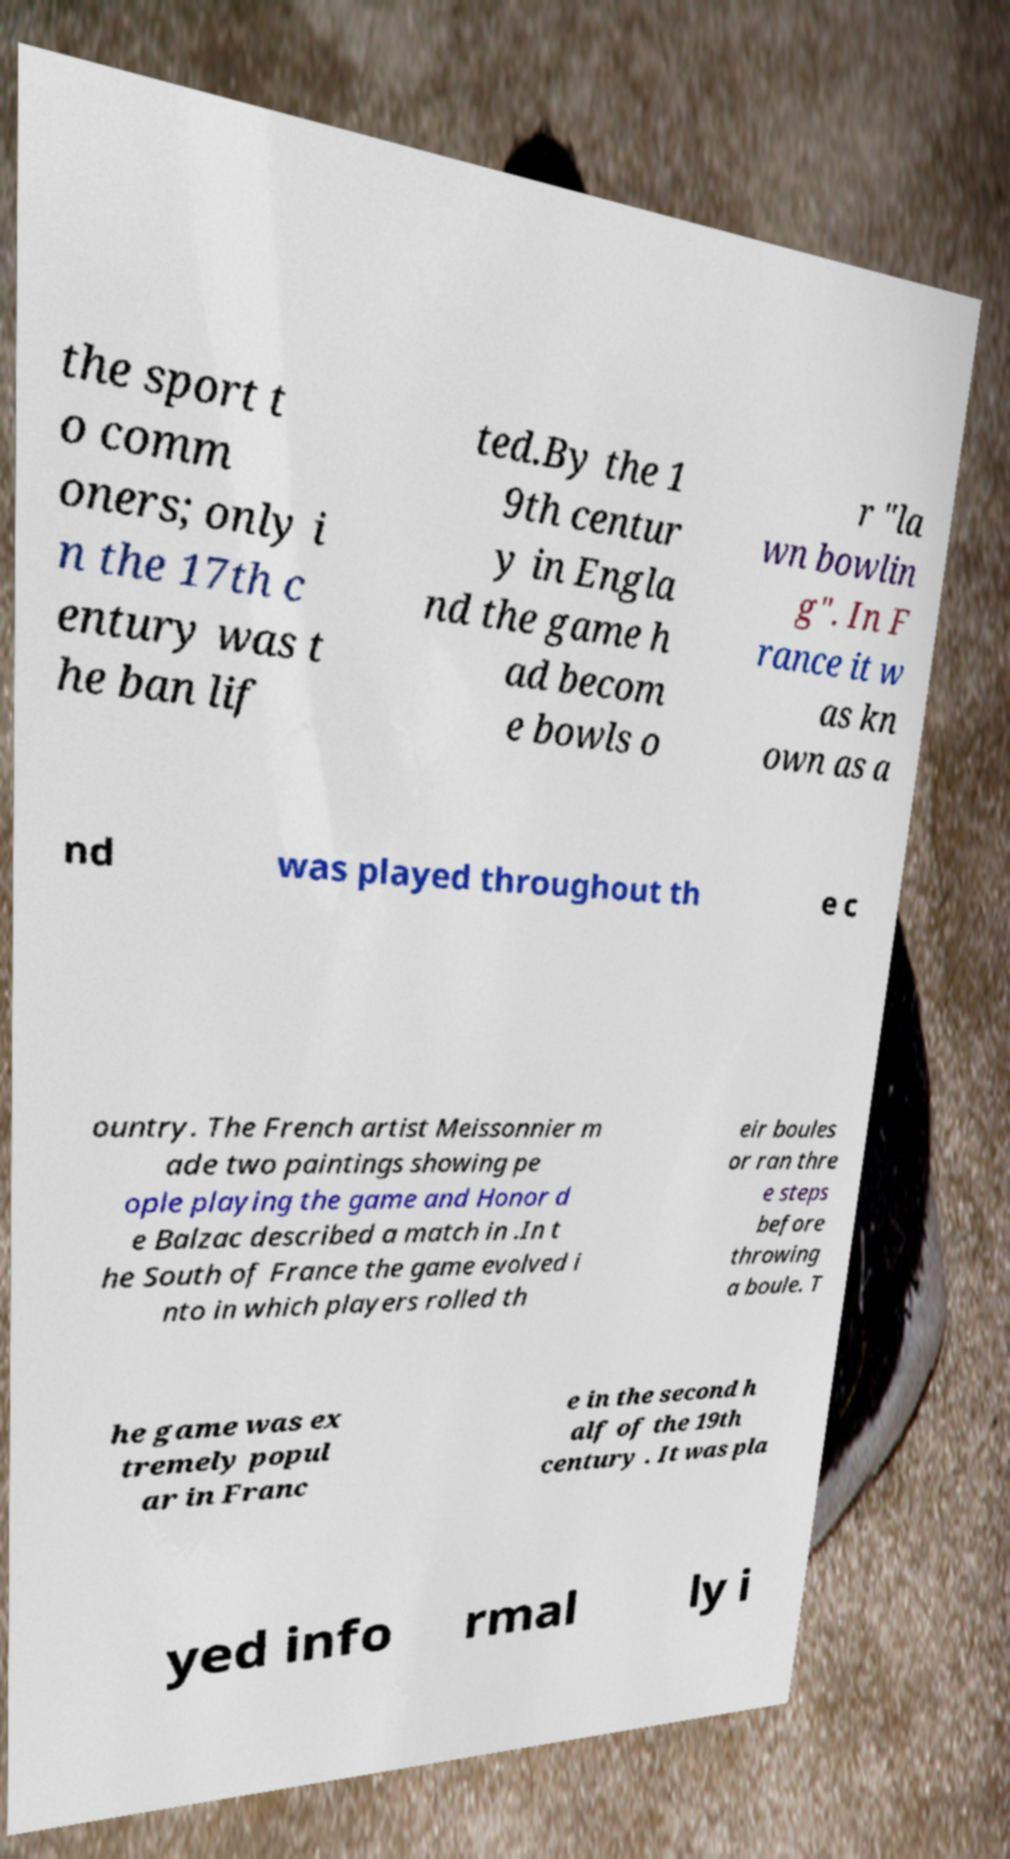There's text embedded in this image that I need extracted. Can you transcribe it verbatim? the sport t o comm oners; only i n the 17th c entury was t he ban lif ted.By the 1 9th centur y in Engla nd the game h ad becom e bowls o r "la wn bowlin g". In F rance it w as kn own as a nd was played throughout th e c ountry. The French artist Meissonnier m ade two paintings showing pe ople playing the game and Honor d e Balzac described a match in .In t he South of France the game evolved i nto in which players rolled th eir boules or ran thre e steps before throwing a boule. T he game was ex tremely popul ar in Franc e in the second h alf of the 19th century . It was pla yed info rmal ly i 